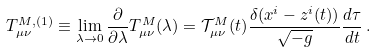<formula> <loc_0><loc_0><loc_500><loc_500>T ^ { M , ( 1 ) } _ { \mu \nu } \equiv \lim _ { \lambda \rightarrow 0 } \frac { \partial } { \partial \lambda } T ^ { M } _ { \mu \nu } ( \lambda ) = \mathcal { T } ^ { M } _ { \mu \nu } ( t ) \frac { \delta ( x ^ { i } - z ^ { i } ( t ) ) } { \sqrt { - g } } \frac { d \tau } { d t } \, .</formula> 